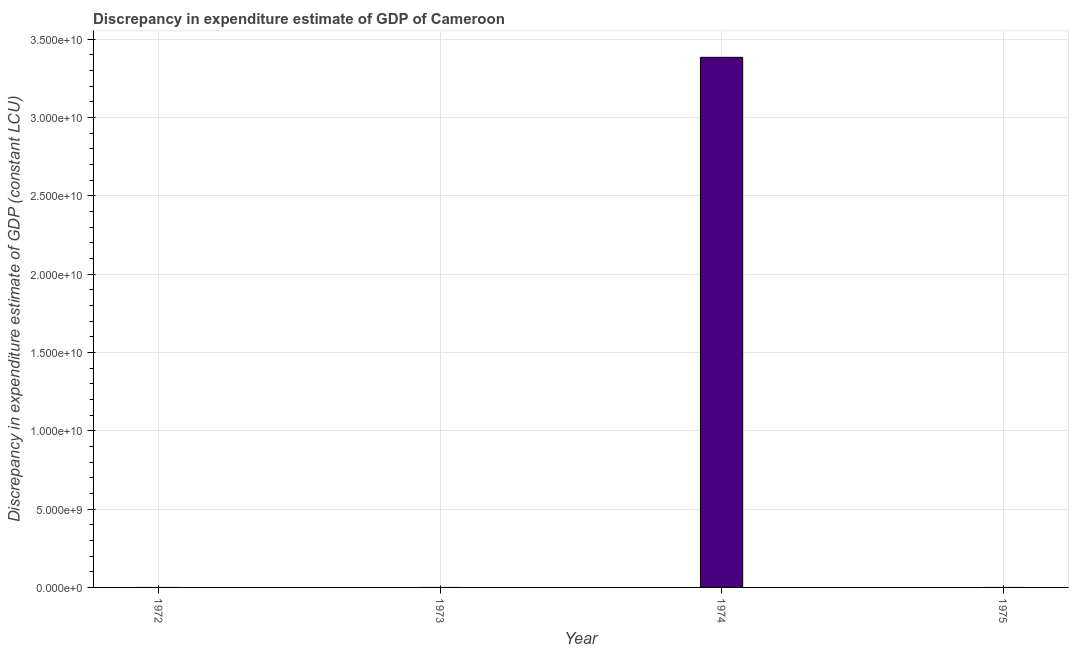Does the graph contain grids?
Provide a short and direct response. Yes. What is the title of the graph?
Provide a succinct answer. Discrepancy in expenditure estimate of GDP of Cameroon. What is the label or title of the X-axis?
Keep it short and to the point. Year. What is the label or title of the Y-axis?
Your answer should be very brief. Discrepancy in expenditure estimate of GDP (constant LCU). What is the discrepancy in expenditure estimate of gdp in 1975?
Offer a terse response. 0. Across all years, what is the maximum discrepancy in expenditure estimate of gdp?
Your response must be concise. 3.38e+1. Across all years, what is the minimum discrepancy in expenditure estimate of gdp?
Provide a succinct answer. 0. In which year was the discrepancy in expenditure estimate of gdp maximum?
Provide a succinct answer. 1974. What is the sum of the discrepancy in expenditure estimate of gdp?
Your answer should be compact. 3.38e+1. What is the average discrepancy in expenditure estimate of gdp per year?
Provide a succinct answer. 8.46e+09. What is the median discrepancy in expenditure estimate of gdp?
Your answer should be very brief. 0. What is the difference between the highest and the lowest discrepancy in expenditure estimate of gdp?
Keep it short and to the point. 3.38e+1. In how many years, is the discrepancy in expenditure estimate of gdp greater than the average discrepancy in expenditure estimate of gdp taken over all years?
Your answer should be very brief. 1. Are all the bars in the graph horizontal?
Ensure brevity in your answer.  No. What is the difference between two consecutive major ticks on the Y-axis?
Give a very brief answer. 5.00e+09. What is the Discrepancy in expenditure estimate of GDP (constant LCU) in 1974?
Offer a very short reply. 3.38e+1. 